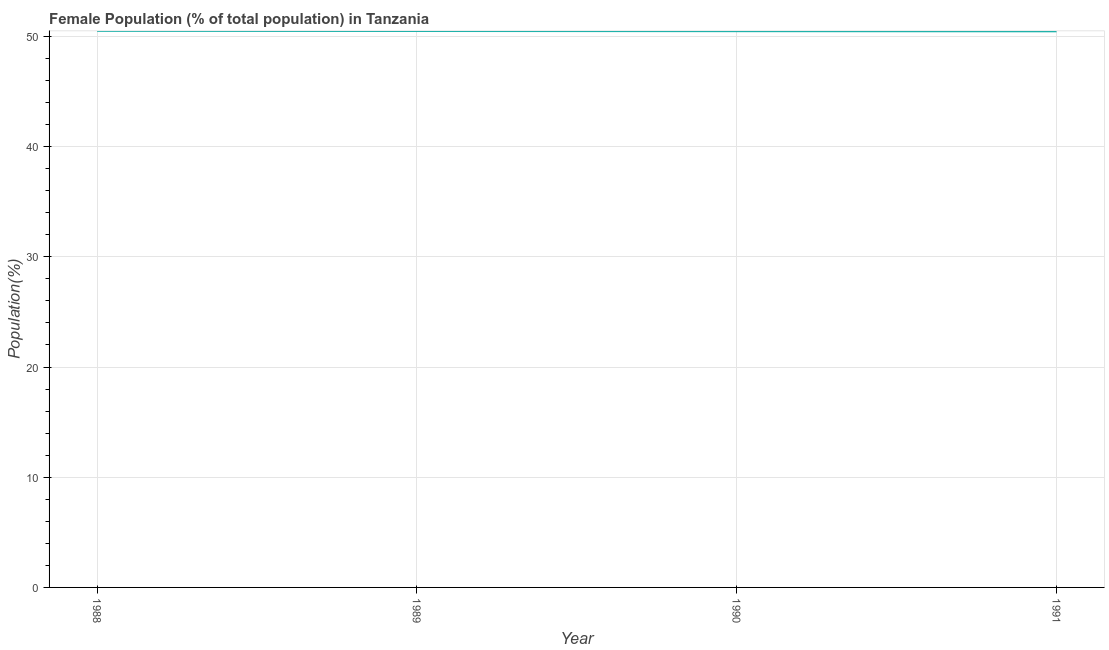What is the female population in 1988?
Provide a short and direct response. 50.5. Across all years, what is the maximum female population?
Give a very brief answer. 50.5. Across all years, what is the minimum female population?
Give a very brief answer. 50.46. What is the sum of the female population?
Your answer should be compact. 201.93. What is the difference between the female population in 1988 and 1990?
Provide a short and direct response. 0.03. What is the average female population per year?
Your answer should be very brief. 50.48. What is the median female population?
Offer a terse response. 50.48. In how many years, is the female population greater than 28 %?
Provide a succinct answer. 4. Do a majority of the years between 1990 and 1988 (inclusive) have female population greater than 6 %?
Give a very brief answer. No. What is the ratio of the female population in 1990 to that in 1991?
Offer a very short reply. 1. Is the difference between the female population in 1990 and 1991 greater than the difference between any two years?
Your answer should be compact. No. What is the difference between the highest and the second highest female population?
Offer a terse response. 0.01. What is the difference between the highest and the lowest female population?
Your answer should be compact. 0.04. Does the female population monotonically increase over the years?
Make the answer very short. No. What is the difference between two consecutive major ticks on the Y-axis?
Ensure brevity in your answer.  10. Are the values on the major ticks of Y-axis written in scientific E-notation?
Provide a short and direct response. No. What is the title of the graph?
Provide a short and direct response. Female Population (% of total population) in Tanzania. What is the label or title of the Y-axis?
Your answer should be compact. Population(%). What is the Population(%) of 1988?
Your answer should be compact. 50.5. What is the Population(%) of 1989?
Your answer should be very brief. 50.49. What is the Population(%) of 1990?
Keep it short and to the point. 50.47. What is the Population(%) of 1991?
Your answer should be compact. 50.46. What is the difference between the Population(%) in 1988 and 1989?
Make the answer very short. 0.01. What is the difference between the Population(%) in 1988 and 1990?
Provide a succinct answer. 0.03. What is the difference between the Population(%) in 1988 and 1991?
Give a very brief answer. 0.04. What is the difference between the Population(%) in 1989 and 1990?
Provide a short and direct response. 0.01. What is the difference between the Population(%) in 1989 and 1991?
Ensure brevity in your answer.  0.03. What is the difference between the Population(%) in 1990 and 1991?
Make the answer very short. 0.01. What is the ratio of the Population(%) in 1988 to that in 1990?
Make the answer very short. 1. What is the ratio of the Population(%) in 1989 to that in 1991?
Offer a very short reply. 1. 